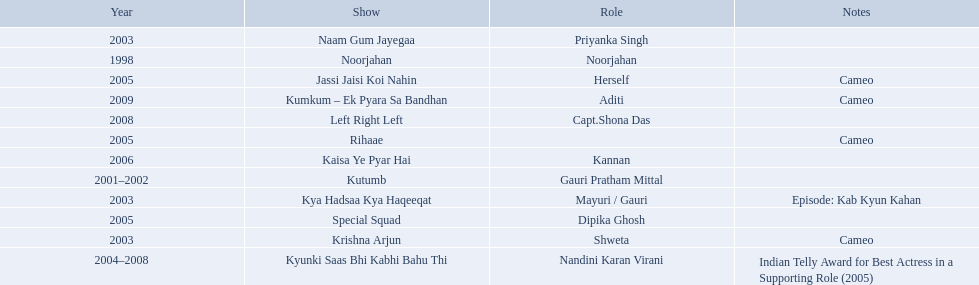What are all of the shows? Noorjahan, Kutumb, Krishna Arjun, Naam Gum Jayegaa, Kya Hadsaa Kya Haqeeqat, Kyunki Saas Bhi Kabhi Bahu Thi, Rihaae, Jassi Jaisi Koi Nahin, Special Squad, Kaisa Ye Pyar Hai, Left Right Left, Kumkum – Ek Pyara Sa Bandhan. When were they in production? 1998, 2001–2002, 2003, 2003, 2003, 2004–2008, 2005, 2005, 2005, 2006, 2008, 2009. And which show was he on for the longest time? Kyunki Saas Bhi Kabhi Bahu Thi. 